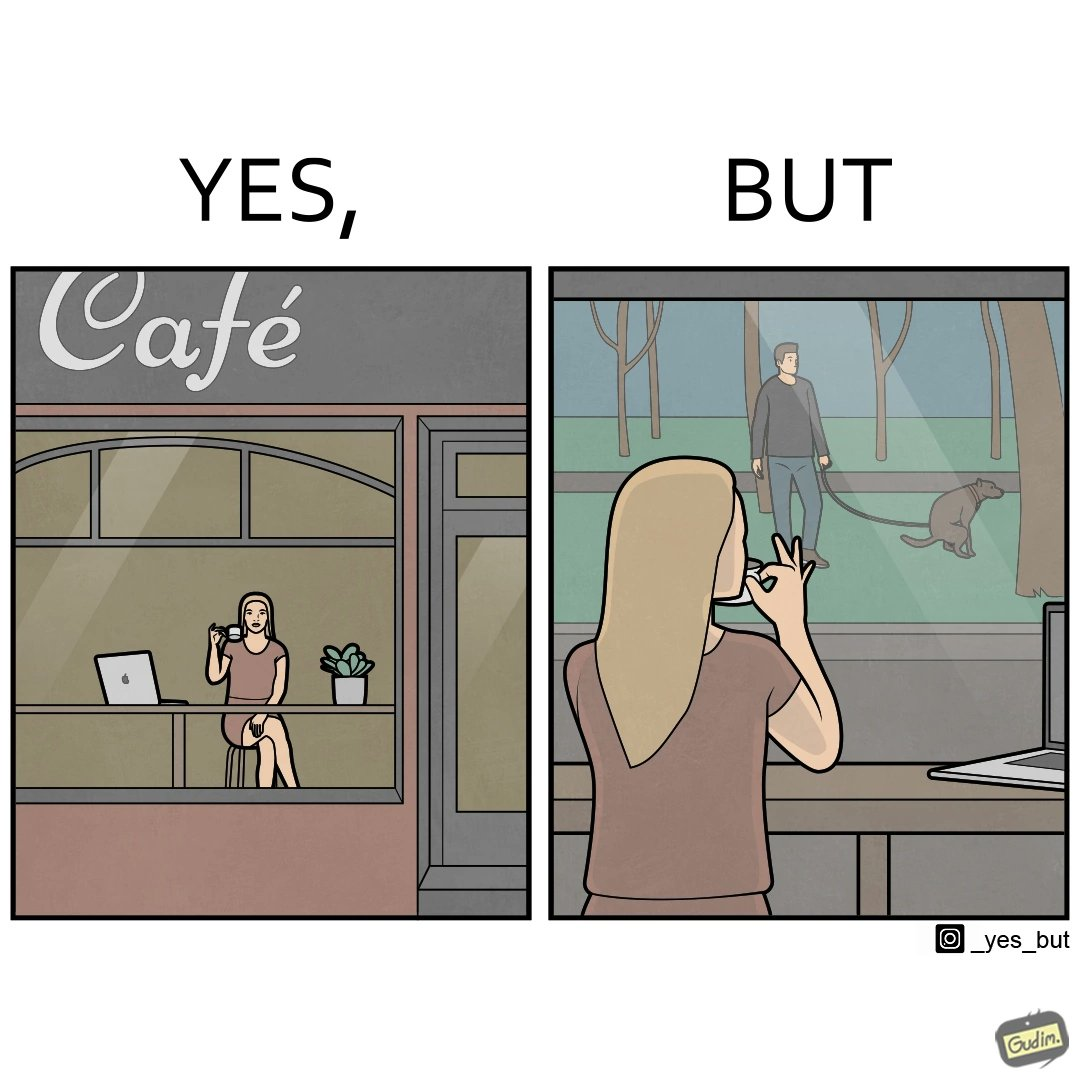Is this a satirical image? Yes, this image is satirical. 